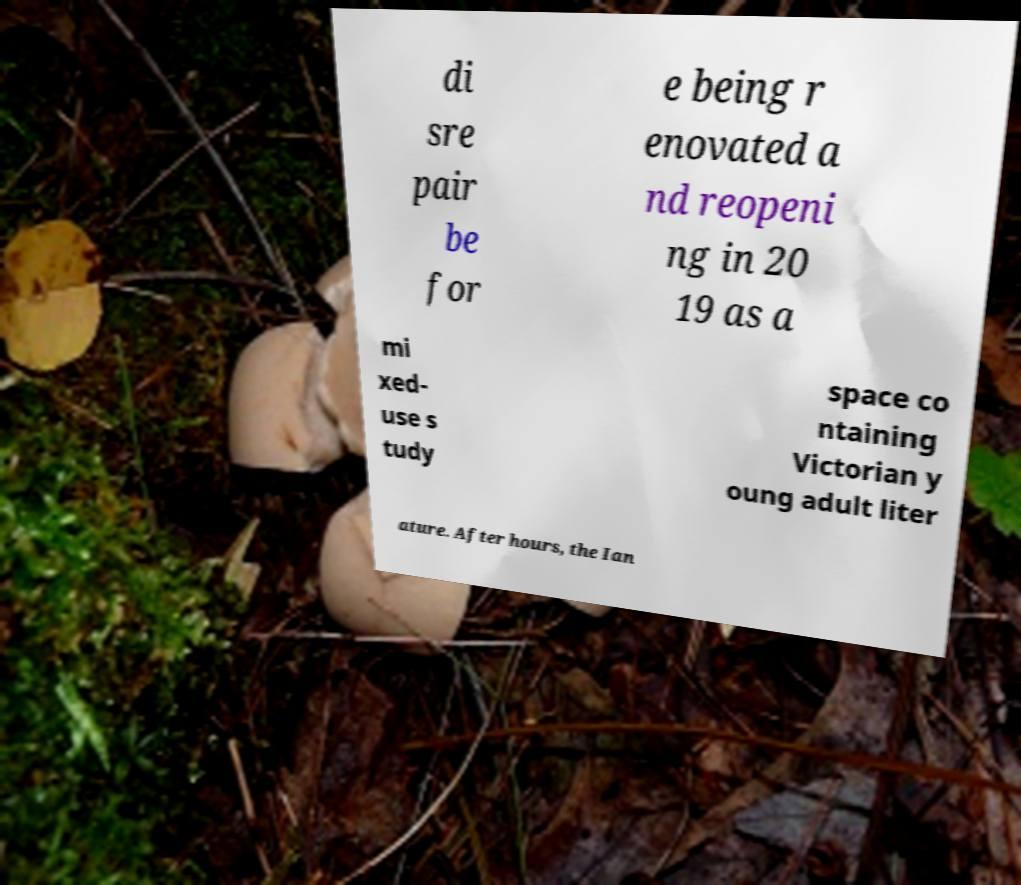I need the written content from this picture converted into text. Can you do that? di sre pair be for e being r enovated a nd reopeni ng in 20 19 as a mi xed- use s tudy space co ntaining Victorian y oung adult liter ature. After hours, the Ian 